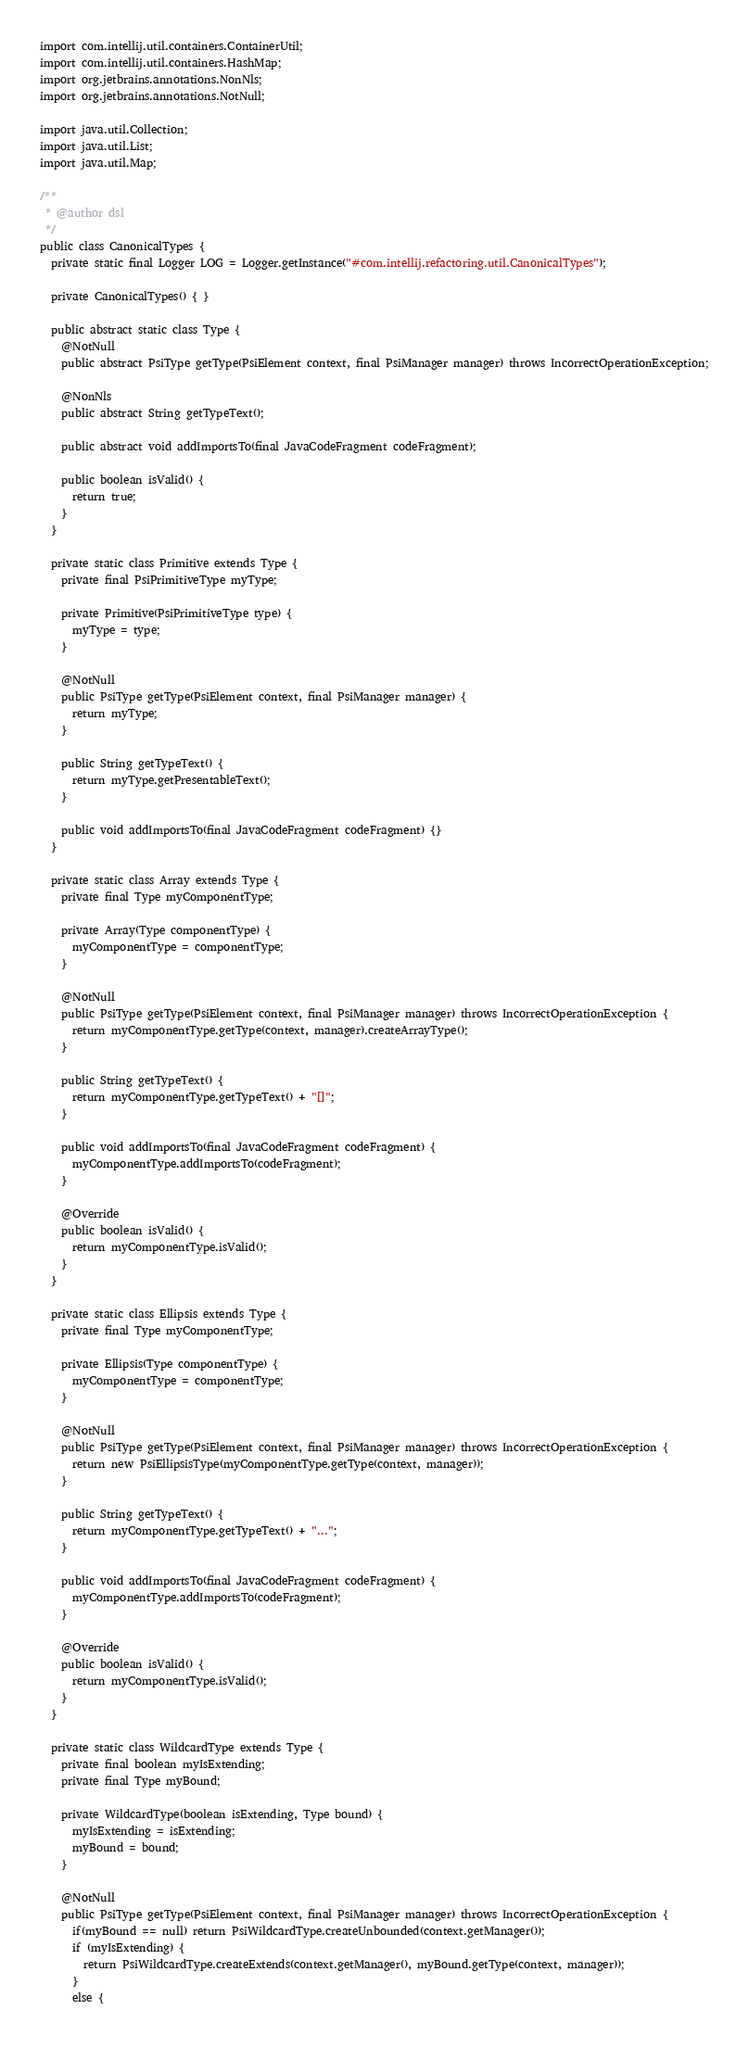Convert code to text. <code><loc_0><loc_0><loc_500><loc_500><_Java_>import com.intellij.util.containers.ContainerUtil;
import com.intellij.util.containers.HashMap;
import org.jetbrains.annotations.NonNls;
import org.jetbrains.annotations.NotNull;

import java.util.Collection;
import java.util.List;
import java.util.Map;

/**
 * @author dsl
 */
public class CanonicalTypes {
  private static final Logger LOG = Logger.getInstance("#com.intellij.refactoring.util.CanonicalTypes");

  private CanonicalTypes() { }

  public abstract static class Type {
    @NotNull
    public abstract PsiType getType(PsiElement context, final PsiManager manager) throws IncorrectOperationException;

    @NonNls
    public abstract String getTypeText();

    public abstract void addImportsTo(final JavaCodeFragment codeFragment);

    public boolean isValid() {
      return true;
    }
  }

  private static class Primitive extends Type {
    private final PsiPrimitiveType myType;

    private Primitive(PsiPrimitiveType type) {
      myType = type;
    }

    @NotNull
    public PsiType getType(PsiElement context, final PsiManager manager) {
      return myType;
    }

    public String getTypeText() {
      return myType.getPresentableText();
    }

    public void addImportsTo(final JavaCodeFragment codeFragment) {}
  }

  private static class Array extends Type {
    private final Type myComponentType;

    private Array(Type componentType) {
      myComponentType = componentType;
    }

    @NotNull
    public PsiType getType(PsiElement context, final PsiManager manager) throws IncorrectOperationException {
      return myComponentType.getType(context, manager).createArrayType();
    }

    public String getTypeText() {
      return myComponentType.getTypeText() + "[]";
    }

    public void addImportsTo(final JavaCodeFragment codeFragment) {
      myComponentType.addImportsTo(codeFragment);
    }

    @Override
    public boolean isValid() {
      return myComponentType.isValid();
    }
  }

  private static class Ellipsis extends Type {
    private final Type myComponentType;

    private Ellipsis(Type componentType) {
      myComponentType = componentType;
    }

    @NotNull
    public PsiType getType(PsiElement context, final PsiManager manager) throws IncorrectOperationException {
      return new PsiEllipsisType(myComponentType.getType(context, manager));
    }

    public String getTypeText() {
      return myComponentType.getTypeText() + "...";
    }

    public void addImportsTo(final JavaCodeFragment codeFragment) {
      myComponentType.addImportsTo(codeFragment);
    }

    @Override
    public boolean isValid() {
      return myComponentType.isValid();
    }
  }

  private static class WildcardType extends Type {
    private final boolean myIsExtending;
    private final Type myBound;

    private WildcardType(boolean isExtending, Type bound) {
      myIsExtending = isExtending;
      myBound = bound;
    }

    @NotNull
    public PsiType getType(PsiElement context, final PsiManager manager) throws IncorrectOperationException {
      if(myBound == null) return PsiWildcardType.createUnbounded(context.getManager());
      if (myIsExtending) {
        return PsiWildcardType.createExtends(context.getManager(), myBound.getType(context, manager));
      }
      else {</code> 